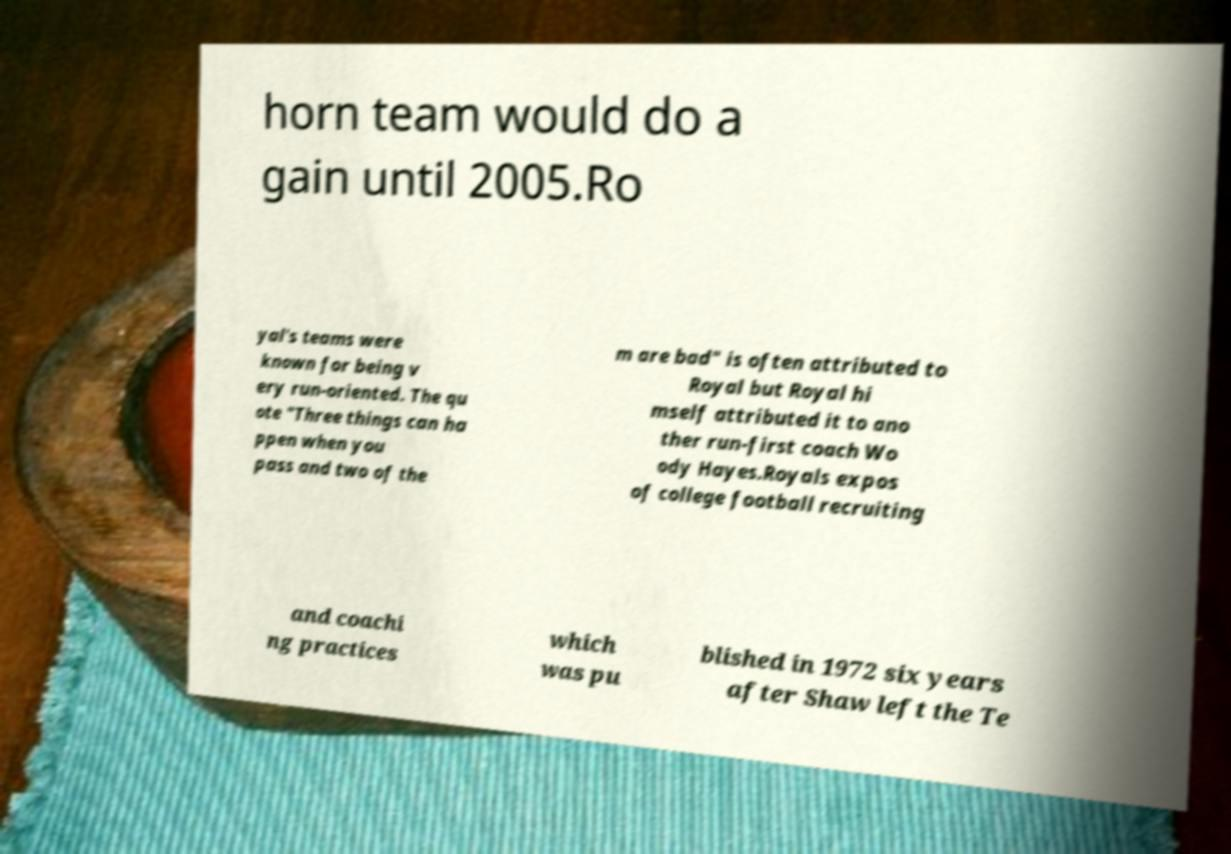I need the written content from this picture converted into text. Can you do that? horn team would do a gain until 2005.Ro yal's teams were known for being v ery run-oriented. The qu ote "Three things can ha ppen when you pass and two of the m are bad" is often attributed to Royal but Royal hi mself attributed it to ano ther run-first coach Wo ody Hayes.Royals expos of college football recruiting and coachi ng practices which was pu blished in 1972 six years after Shaw left the Te 